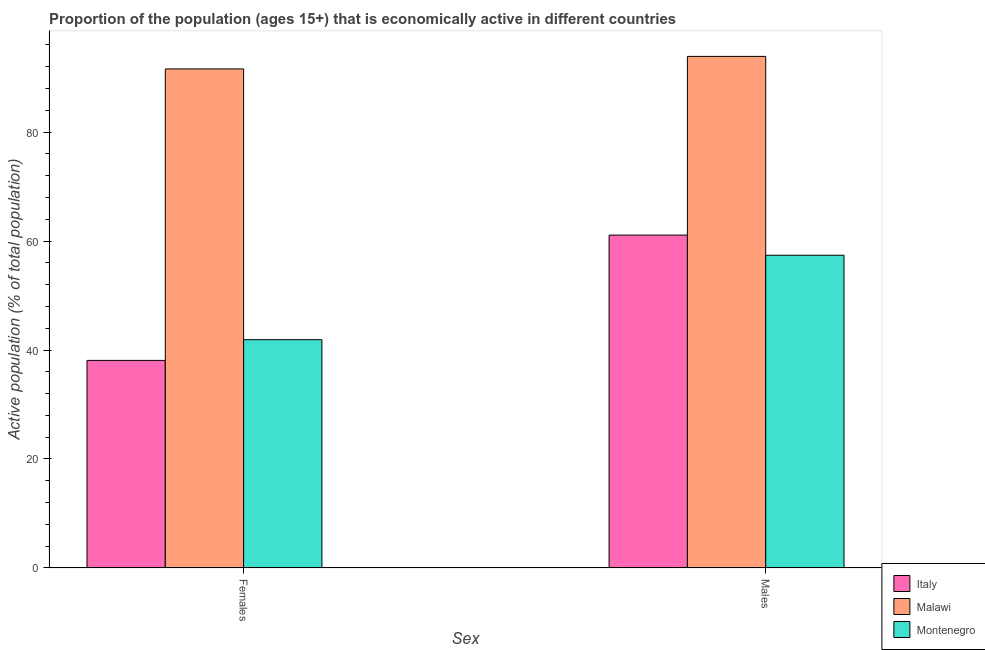Are the number of bars on each tick of the X-axis equal?
Your answer should be very brief. Yes. How many bars are there on the 1st tick from the right?
Your answer should be very brief. 3. What is the label of the 2nd group of bars from the left?
Your answer should be compact. Males. What is the percentage of economically active male population in Montenegro?
Give a very brief answer. 57.4. Across all countries, what is the maximum percentage of economically active female population?
Provide a succinct answer. 91.6. Across all countries, what is the minimum percentage of economically active male population?
Offer a very short reply. 57.4. In which country was the percentage of economically active female population maximum?
Your answer should be compact. Malawi. In which country was the percentage of economically active female population minimum?
Offer a very short reply. Italy. What is the total percentage of economically active female population in the graph?
Provide a short and direct response. 171.6. What is the difference between the percentage of economically active male population in Malawi and that in Montenegro?
Your response must be concise. 36.5. What is the difference between the percentage of economically active male population in Montenegro and the percentage of economically active female population in Italy?
Provide a succinct answer. 19.3. What is the average percentage of economically active female population per country?
Keep it short and to the point. 57.2. What is the difference between the percentage of economically active male population and percentage of economically active female population in Malawi?
Your answer should be very brief. 2.3. In how many countries, is the percentage of economically active female population greater than 28 %?
Your response must be concise. 3. What is the ratio of the percentage of economically active female population in Malawi to that in Italy?
Your response must be concise. 2.4. What does the 2nd bar from the left in Females represents?
Make the answer very short. Malawi. How many bars are there?
Keep it short and to the point. 6. How many countries are there in the graph?
Provide a succinct answer. 3. What is the difference between two consecutive major ticks on the Y-axis?
Your answer should be very brief. 20. Does the graph contain grids?
Provide a short and direct response. No. Where does the legend appear in the graph?
Your answer should be very brief. Bottom right. What is the title of the graph?
Ensure brevity in your answer.  Proportion of the population (ages 15+) that is economically active in different countries. What is the label or title of the X-axis?
Provide a short and direct response. Sex. What is the label or title of the Y-axis?
Keep it short and to the point. Active population (% of total population). What is the Active population (% of total population) in Italy in Females?
Keep it short and to the point. 38.1. What is the Active population (% of total population) in Malawi in Females?
Ensure brevity in your answer.  91.6. What is the Active population (% of total population) in Montenegro in Females?
Your answer should be very brief. 41.9. What is the Active population (% of total population) in Italy in Males?
Your response must be concise. 61.1. What is the Active population (% of total population) of Malawi in Males?
Offer a very short reply. 93.9. What is the Active population (% of total population) of Montenegro in Males?
Offer a terse response. 57.4. Across all Sex, what is the maximum Active population (% of total population) of Italy?
Your response must be concise. 61.1. Across all Sex, what is the maximum Active population (% of total population) of Malawi?
Provide a short and direct response. 93.9. Across all Sex, what is the maximum Active population (% of total population) in Montenegro?
Provide a short and direct response. 57.4. Across all Sex, what is the minimum Active population (% of total population) in Italy?
Your answer should be compact. 38.1. Across all Sex, what is the minimum Active population (% of total population) of Malawi?
Keep it short and to the point. 91.6. Across all Sex, what is the minimum Active population (% of total population) in Montenegro?
Provide a short and direct response. 41.9. What is the total Active population (% of total population) in Italy in the graph?
Your response must be concise. 99.2. What is the total Active population (% of total population) in Malawi in the graph?
Your answer should be very brief. 185.5. What is the total Active population (% of total population) of Montenegro in the graph?
Your response must be concise. 99.3. What is the difference between the Active population (% of total population) of Italy in Females and that in Males?
Make the answer very short. -23. What is the difference between the Active population (% of total population) in Montenegro in Females and that in Males?
Give a very brief answer. -15.5. What is the difference between the Active population (% of total population) of Italy in Females and the Active population (% of total population) of Malawi in Males?
Provide a short and direct response. -55.8. What is the difference between the Active population (% of total population) in Italy in Females and the Active population (% of total population) in Montenegro in Males?
Ensure brevity in your answer.  -19.3. What is the difference between the Active population (% of total population) in Malawi in Females and the Active population (% of total population) in Montenegro in Males?
Provide a succinct answer. 34.2. What is the average Active population (% of total population) of Italy per Sex?
Provide a short and direct response. 49.6. What is the average Active population (% of total population) of Malawi per Sex?
Your response must be concise. 92.75. What is the average Active population (% of total population) in Montenegro per Sex?
Make the answer very short. 49.65. What is the difference between the Active population (% of total population) in Italy and Active population (% of total population) in Malawi in Females?
Your response must be concise. -53.5. What is the difference between the Active population (% of total population) of Malawi and Active population (% of total population) of Montenegro in Females?
Ensure brevity in your answer.  49.7. What is the difference between the Active population (% of total population) in Italy and Active population (% of total population) in Malawi in Males?
Keep it short and to the point. -32.8. What is the difference between the Active population (% of total population) of Italy and Active population (% of total population) of Montenegro in Males?
Your answer should be compact. 3.7. What is the difference between the Active population (% of total population) in Malawi and Active population (% of total population) in Montenegro in Males?
Your response must be concise. 36.5. What is the ratio of the Active population (% of total population) of Italy in Females to that in Males?
Make the answer very short. 0.62. What is the ratio of the Active population (% of total population) of Malawi in Females to that in Males?
Offer a terse response. 0.98. What is the ratio of the Active population (% of total population) in Montenegro in Females to that in Males?
Ensure brevity in your answer.  0.73. What is the difference between the highest and the second highest Active population (% of total population) of Italy?
Give a very brief answer. 23. What is the difference between the highest and the second highest Active population (% of total population) of Montenegro?
Offer a terse response. 15.5. What is the difference between the highest and the lowest Active population (% of total population) of Italy?
Ensure brevity in your answer.  23. What is the difference between the highest and the lowest Active population (% of total population) of Malawi?
Keep it short and to the point. 2.3. 